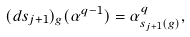Convert formula to latex. <formula><loc_0><loc_0><loc_500><loc_500>( d s _ { j + 1 } ) _ { g } ( \alpha ^ { q - 1 } ) = \alpha _ { s _ { j + 1 } ( g ) } ^ { q } ,</formula> 